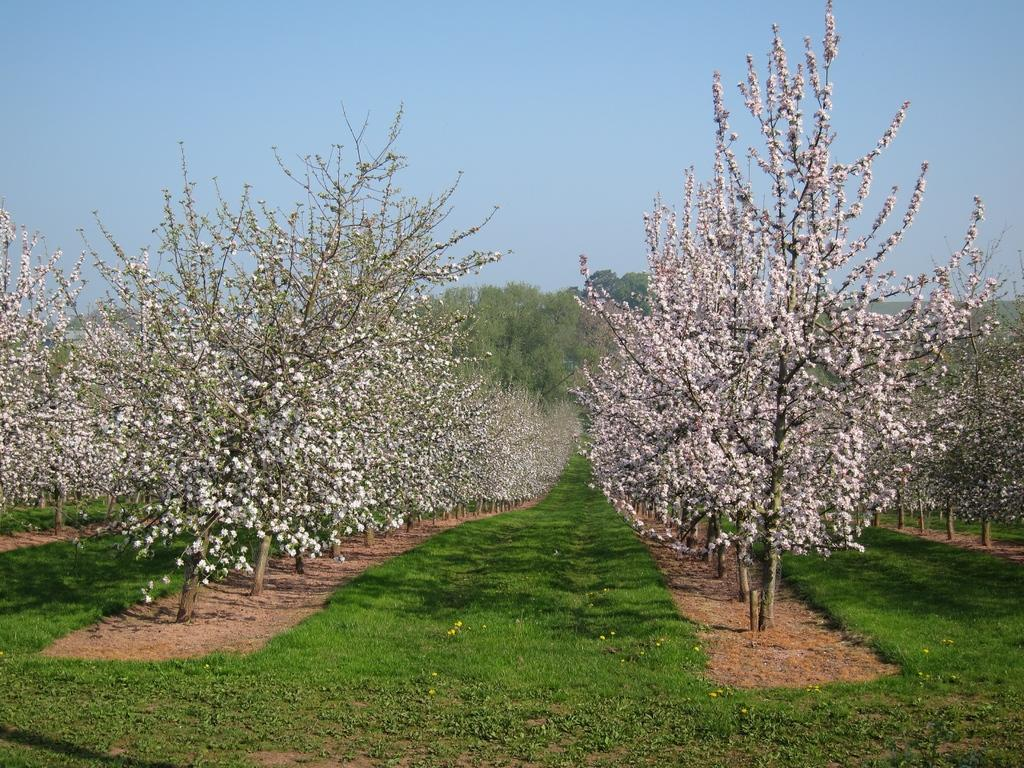What type of terrain is visible at the bottom of the image? There is grass and soil at the bottom of the picture. What can be seen in the background of the image? There are trees in the background of the image. What is visible at the top of the image? The sky is visible at the top of the image. What color is the sky in the image? The color of the sky is blue. How much hate can be seen in the image? There is no hate present in the image; it features a natural landscape with grass, soil, trees, and a blue sky. 